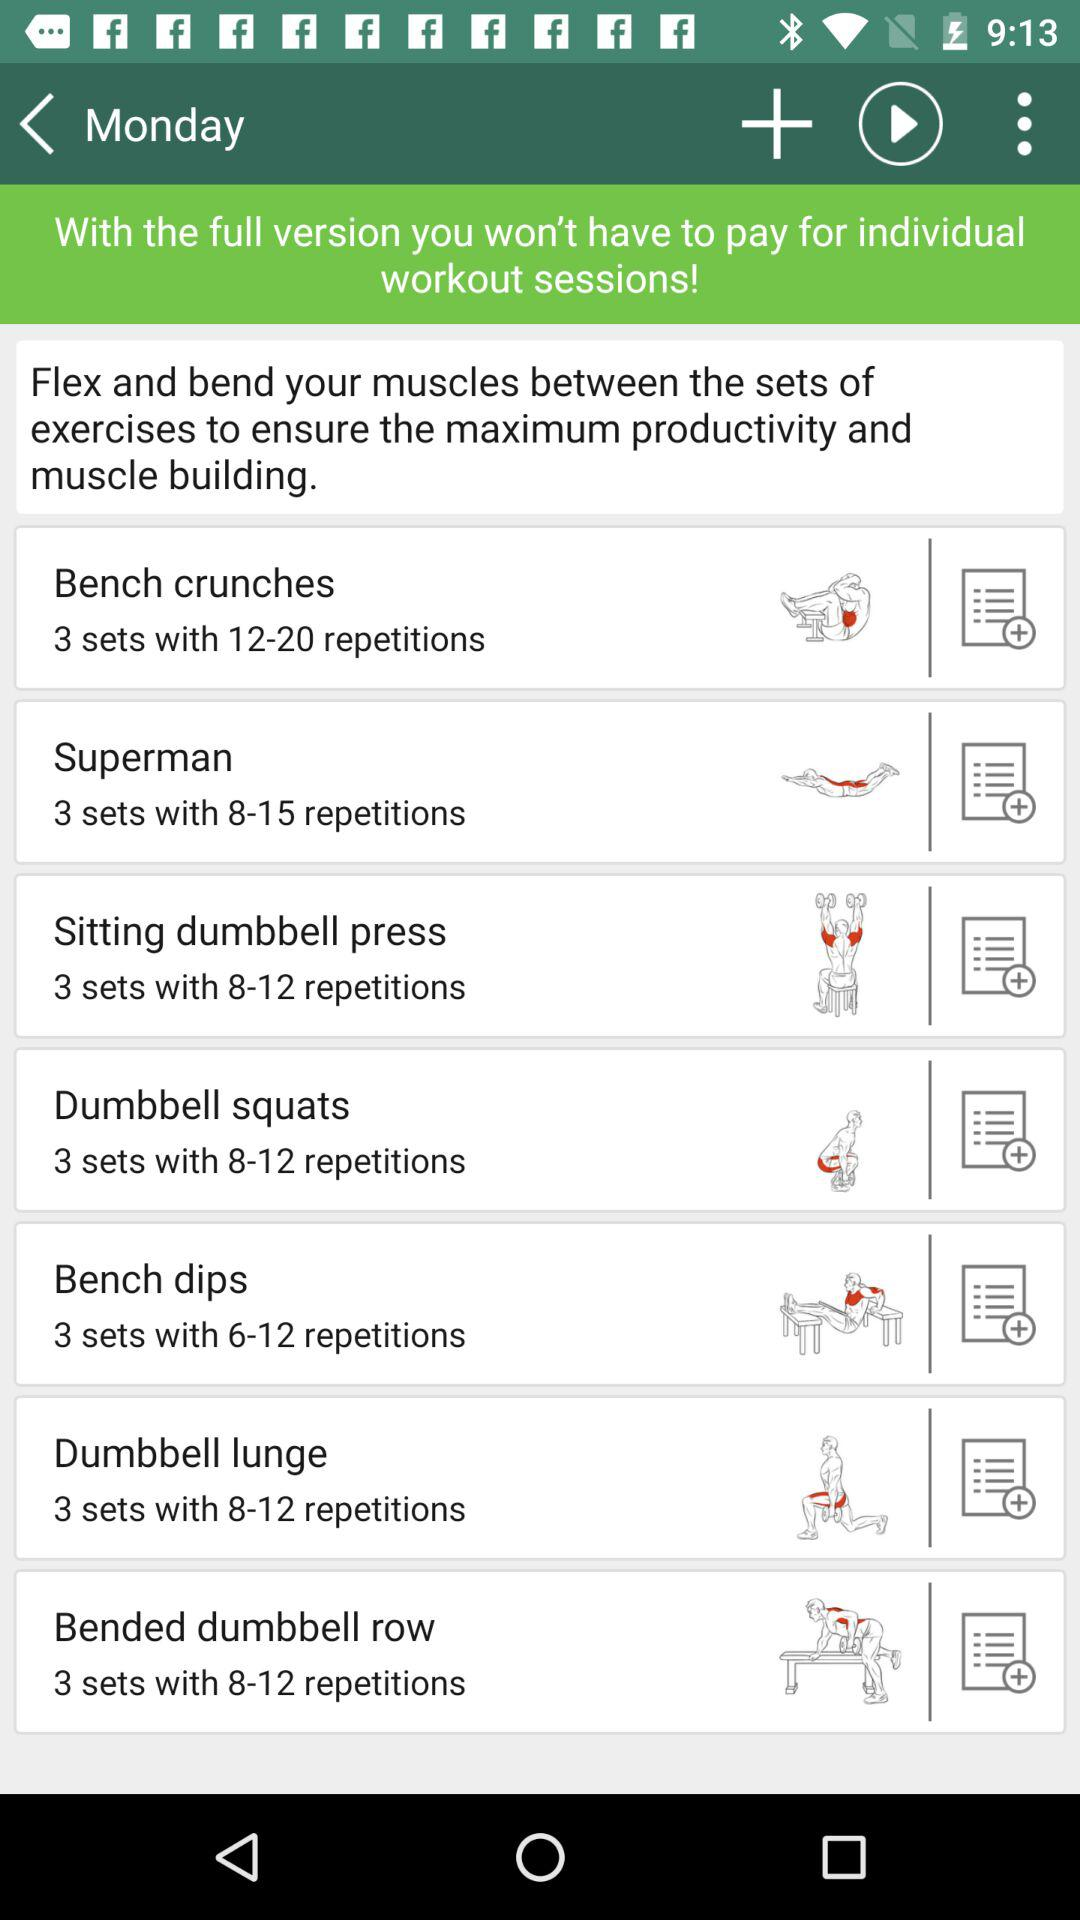What is the number of repetitions for bench dips? The number of repetitions for bench dips are 6 to 12. 